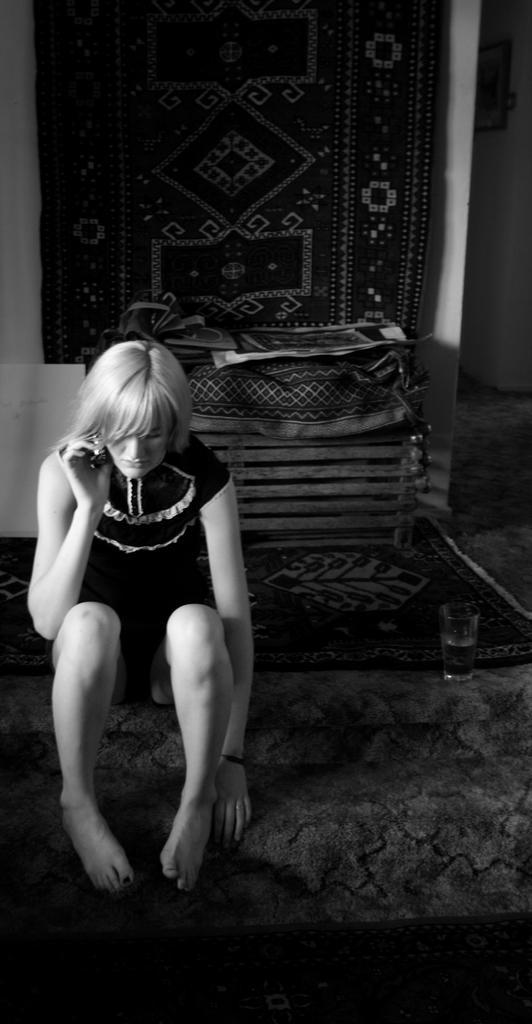Could you give a brief overview of what you see in this image? In this picture we can observe a girl sitting on the floor. On the right side there is a glass placed on the floor. We can observe a wooden box behind her. In the background there is a cloth hanged to the wall. This is a black and white image. 